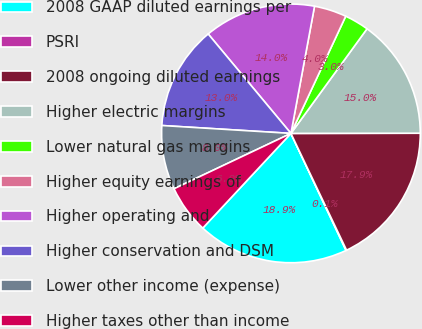<chart> <loc_0><loc_0><loc_500><loc_500><pie_chart><fcel>2008 GAAP diluted earnings per<fcel>PSRI<fcel>2008 ongoing diluted earnings<fcel>Higher electric margins<fcel>Lower natural gas margins<fcel>Higher equity earnings of<fcel>Higher operating and<fcel>Higher conservation and DSM<fcel>Lower other income (expense)<fcel>Higher taxes other than income<nl><fcel>18.94%<fcel>0.07%<fcel>17.95%<fcel>14.97%<fcel>3.05%<fcel>4.04%<fcel>13.97%<fcel>12.98%<fcel>8.01%<fcel>6.03%<nl></chart> 